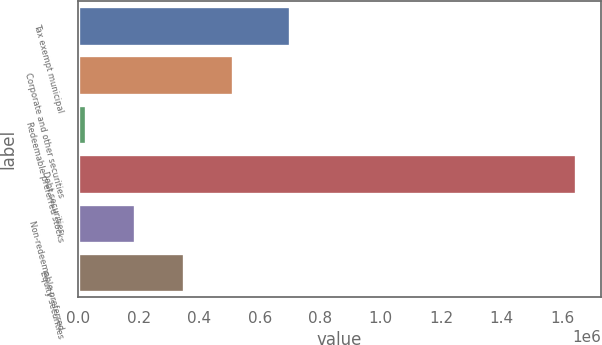Convert chart. <chart><loc_0><loc_0><loc_500><loc_500><bar_chart><fcel>Tax exempt municipal<fcel>Corporate and other securities<fcel>Redeemable preferred stocks<fcel>Debt securities<fcel>Non-redeemable preferred<fcel>Equity securities<nl><fcel>698842<fcel>512451<fcel>27047<fcel>1.64506e+06<fcel>188848<fcel>350650<nl></chart> 